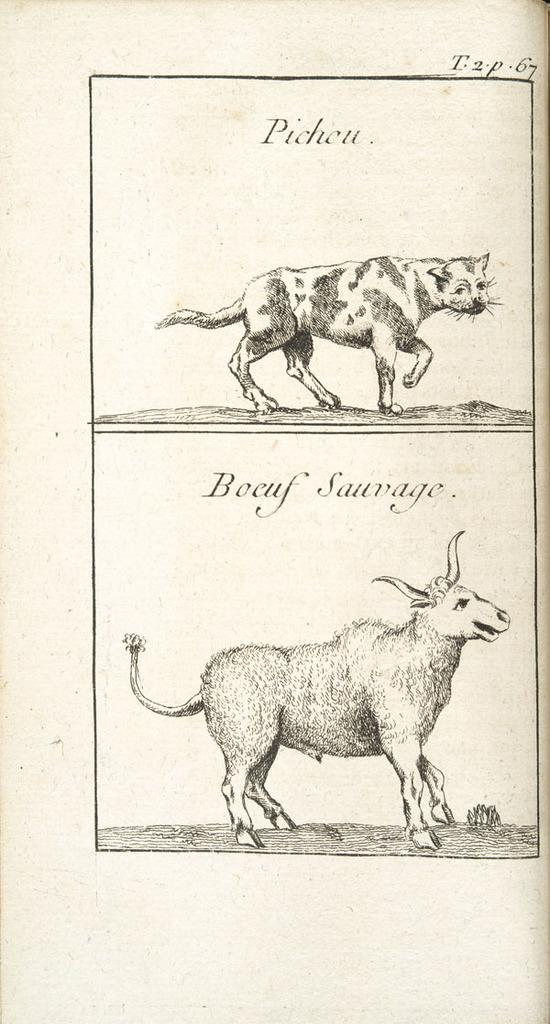What can be seen in the image involving animals? There is a depiction of two animals in the image. What else is present in the image besides the animals? There is text written on the top of the image and text written in the center of the image. How does the grip of the animals affect their ability to whistle in the image? There is no mention of grips or whistling in the image; it only features a depiction of two animals and text. 